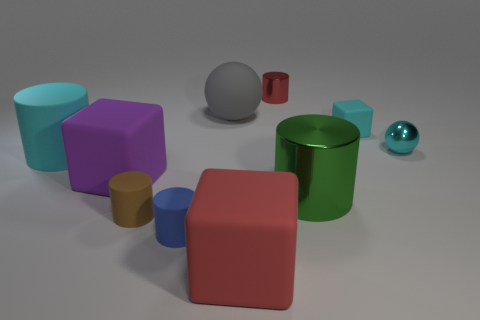Subtract 1 cylinders. How many cylinders are left? 4 Subtract all red cylinders. How many cylinders are left? 4 Subtract all small rubber cylinders. How many cylinders are left? 3 Subtract all gray cylinders. Subtract all blue spheres. How many cylinders are left? 5 Subtract all cubes. How many objects are left? 7 Add 8 big cyan matte objects. How many big cyan matte objects are left? 9 Add 1 blue objects. How many blue objects exist? 2 Subtract 0 blue cubes. How many objects are left? 10 Subtract all big brown matte objects. Subtract all tiny red shiny things. How many objects are left? 9 